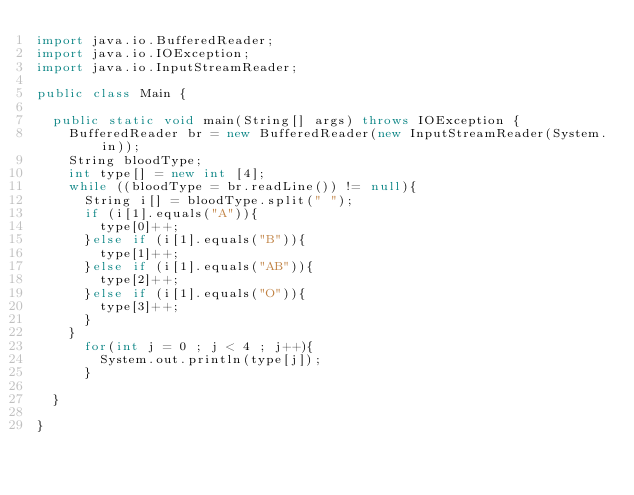Convert code to text. <code><loc_0><loc_0><loc_500><loc_500><_Java_>import java.io.BufferedReader;
import java.io.IOException;
import java.io.InputStreamReader;

public class Main {

	public static void main(String[] args) throws IOException {
		BufferedReader br = new BufferedReader(new InputStreamReader(System.in));
		String bloodType;
		int type[] = new int [4];
		while ((bloodType = br.readLine()) != null){
			String i[] = bloodType.split(" ");
			if (i[1].equals("A")){
				type[0]++;
			}else if (i[1].equals("B")){
				type[1]++;
			}else if (i[1].equals("AB")){
				type[2]++;
			}else if (i[1].equals("O")){
				type[3]++;
			}
		}
		  for(int j = 0 ; j < 4 ; j++){
			  System.out.println(type[j]);
		  }

	}

}</code> 